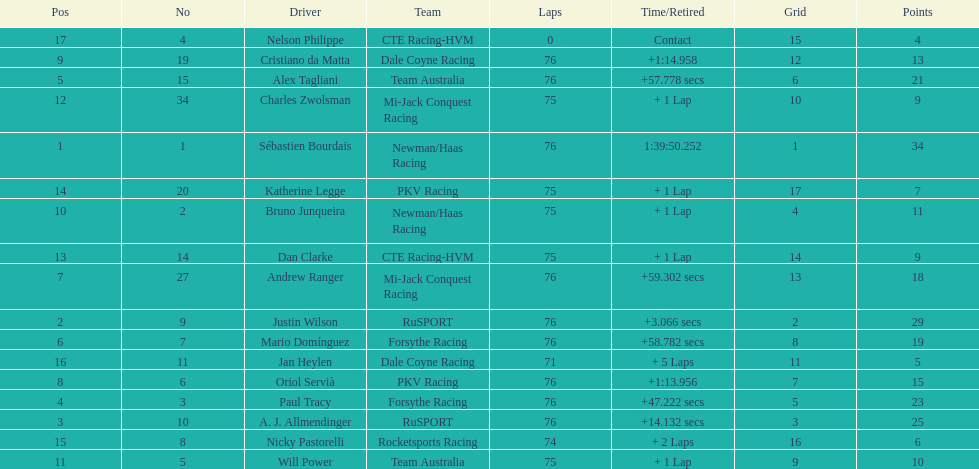What driver earned the most points? Sebastien Bourdais. 